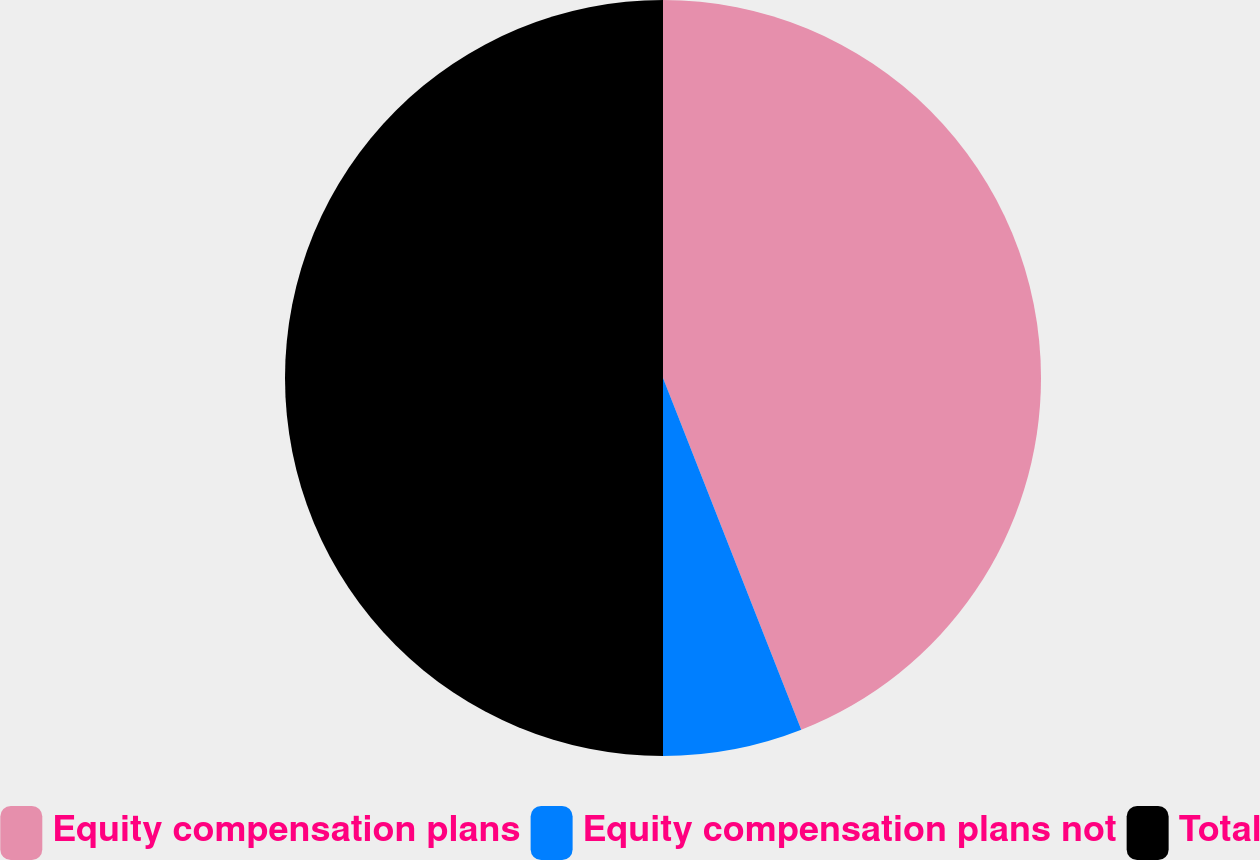Convert chart to OTSL. <chart><loc_0><loc_0><loc_500><loc_500><pie_chart><fcel>Equity compensation plans<fcel>Equity compensation plans not<fcel>Total<nl><fcel>44.04%<fcel>5.96%<fcel>50.0%<nl></chart> 